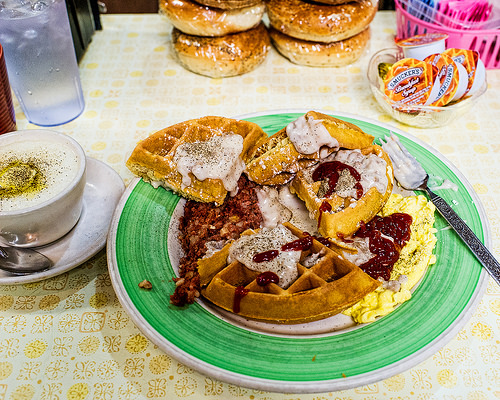<image>
Is the fork on the plate? Yes. Looking at the image, I can see the fork is positioned on top of the plate, with the plate providing support. 